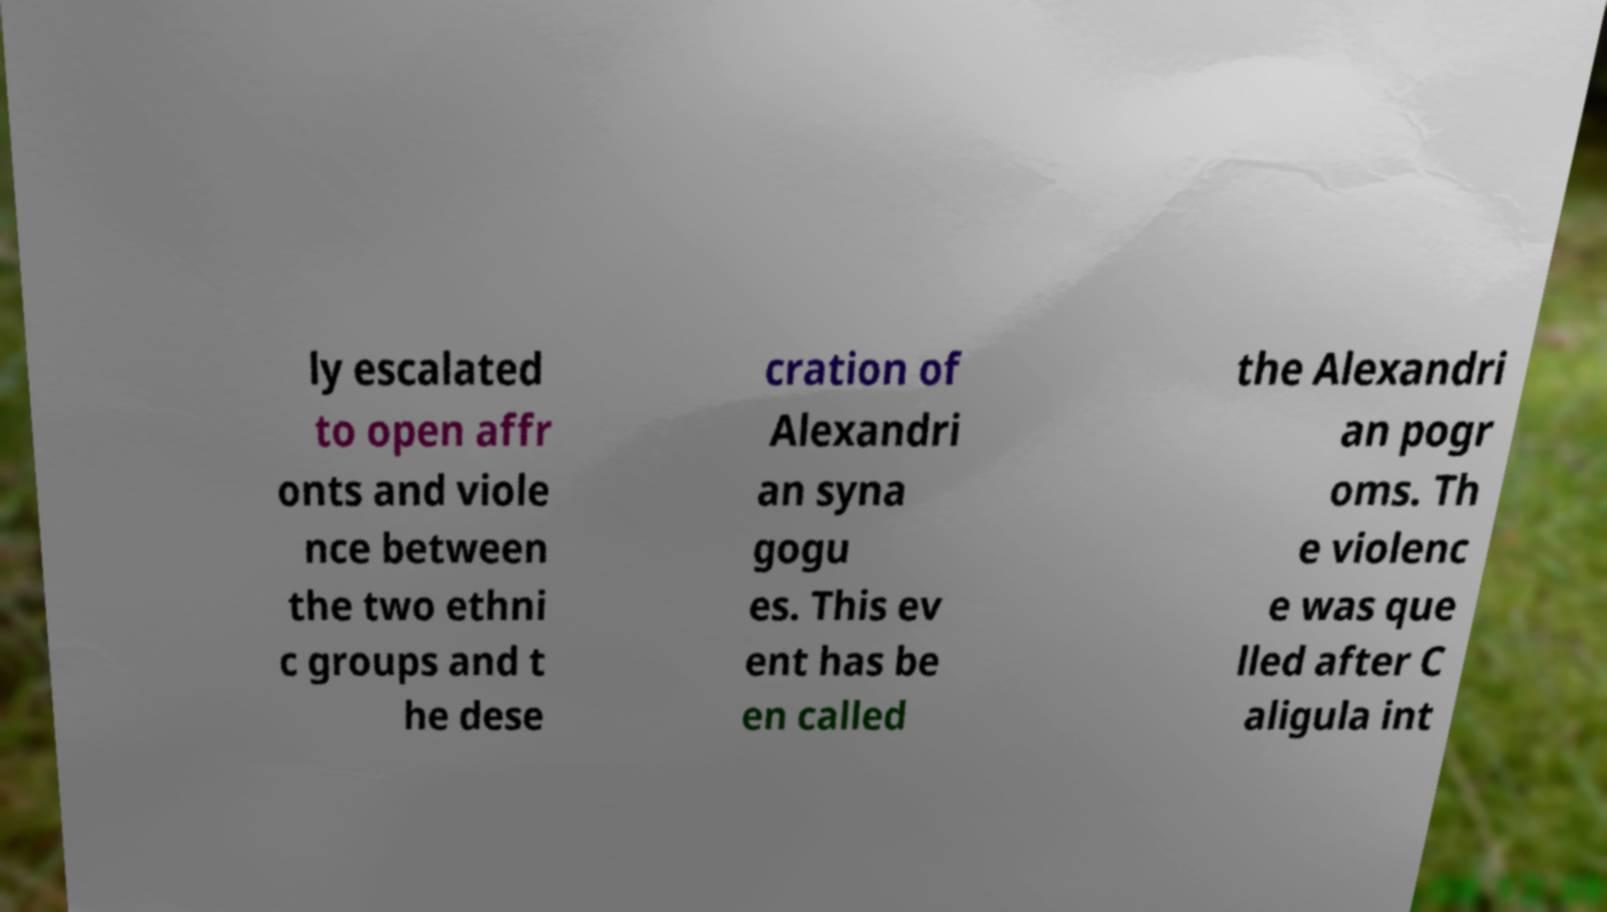For documentation purposes, I need the text within this image transcribed. Could you provide that? ly escalated to open affr onts and viole nce between the two ethni c groups and t he dese cration of Alexandri an syna gogu es. This ev ent has be en called the Alexandri an pogr oms. Th e violenc e was que lled after C aligula int 